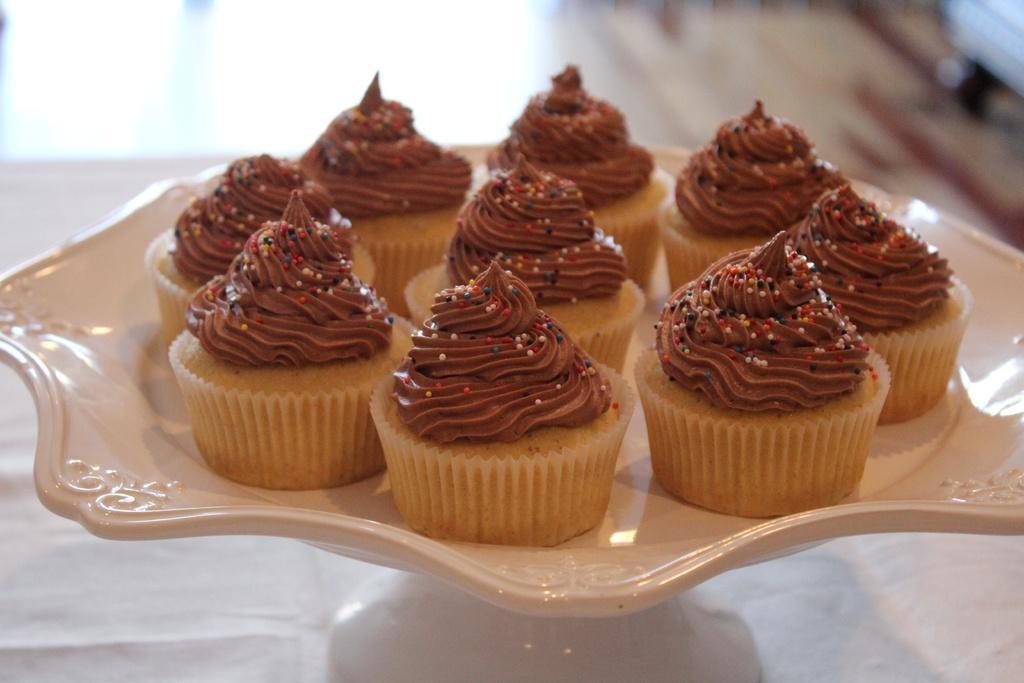Describe this image in one or two sentences. In this picture there are pancakes in a plate. The plate is on the table. The background is blurred. 